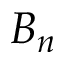<formula> <loc_0><loc_0><loc_500><loc_500>B _ { n }</formula> 